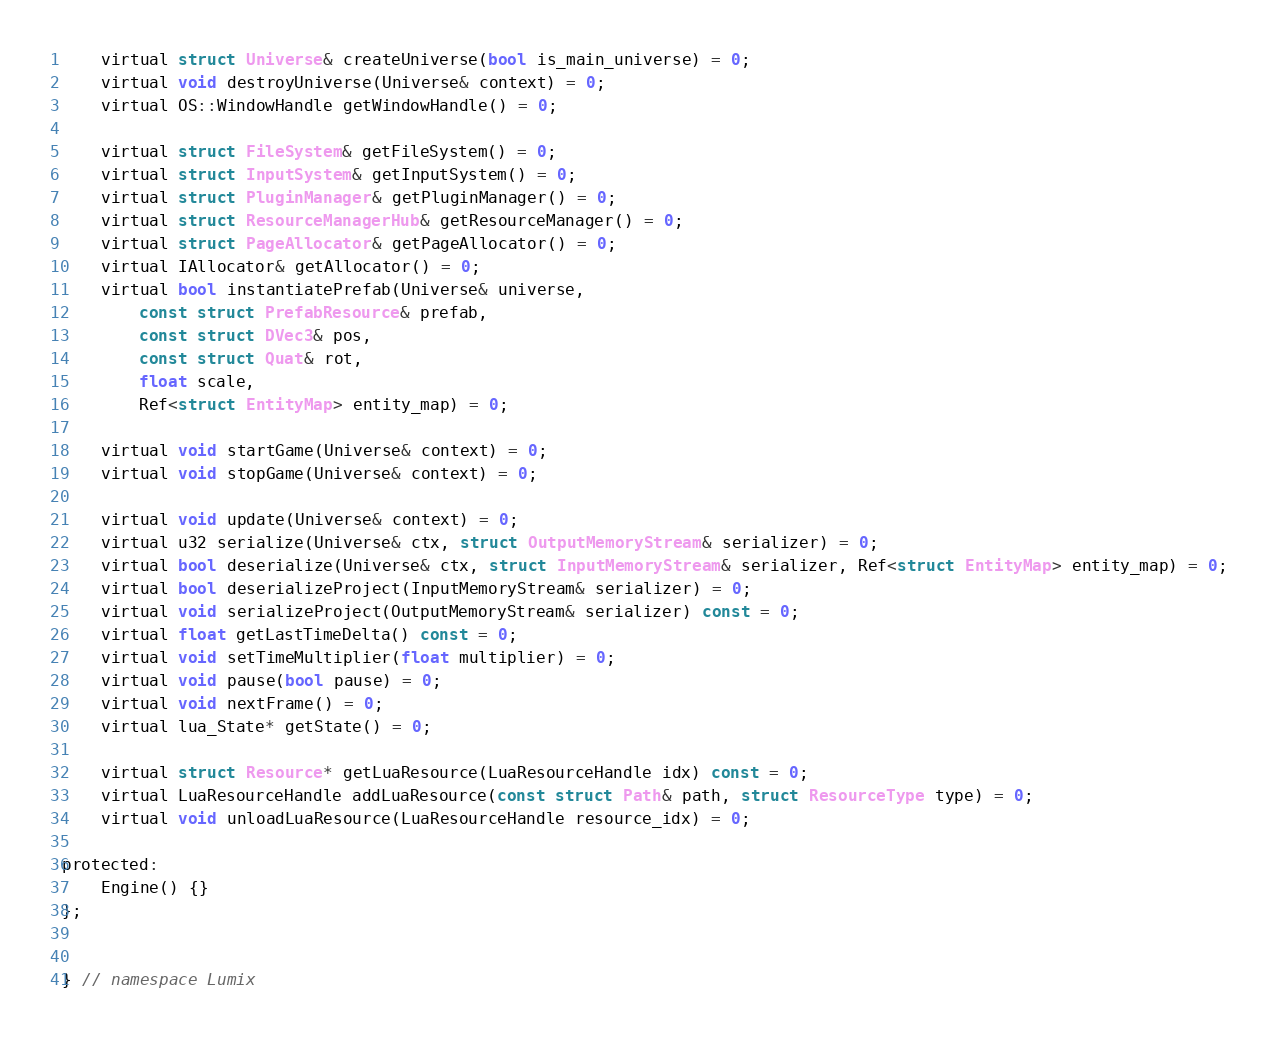Convert code to text. <code><loc_0><loc_0><loc_500><loc_500><_C_>
	virtual struct Universe& createUniverse(bool is_main_universe) = 0;
	virtual void destroyUniverse(Universe& context) = 0;
	virtual OS::WindowHandle getWindowHandle() = 0;

	virtual struct FileSystem& getFileSystem() = 0;
	virtual struct InputSystem& getInputSystem() = 0;
	virtual struct PluginManager& getPluginManager() = 0;
	virtual struct ResourceManagerHub& getResourceManager() = 0;
	virtual struct PageAllocator& getPageAllocator() = 0;
	virtual IAllocator& getAllocator() = 0;
	virtual bool instantiatePrefab(Universe& universe,
		const struct PrefabResource& prefab,
		const struct DVec3& pos,
		const struct Quat& rot,
		float scale,
		Ref<struct EntityMap> entity_map) = 0;

	virtual void startGame(Universe& context) = 0;
	virtual void stopGame(Universe& context) = 0;

	virtual void update(Universe& context) = 0;
	virtual u32 serialize(Universe& ctx, struct OutputMemoryStream& serializer) = 0;
	virtual bool deserialize(Universe& ctx, struct InputMemoryStream& serializer, Ref<struct EntityMap> entity_map) = 0;
	virtual bool deserializeProject(InputMemoryStream& serializer) = 0;
	virtual void serializeProject(OutputMemoryStream& serializer) const = 0;
	virtual float getLastTimeDelta() const = 0;
	virtual void setTimeMultiplier(float multiplier) = 0;
	virtual void pause(bool pause) = 0;
	virtual void nextFrame() = 0;
	virtual lua_State* getState() = 0;

	virtual struct Resource* getLuaResource(LuaResourceHandle idx) const = 0;
	virtual LuaResourceHandle addLuaResource(const struct Path& path, struct ResourceType type) = 0;
	virtual void unloadLuaResource(LuaResourceHandle resource_idx) = 0;

protected:
	Engine() {}
};


} // namespace Lumix
</code> 